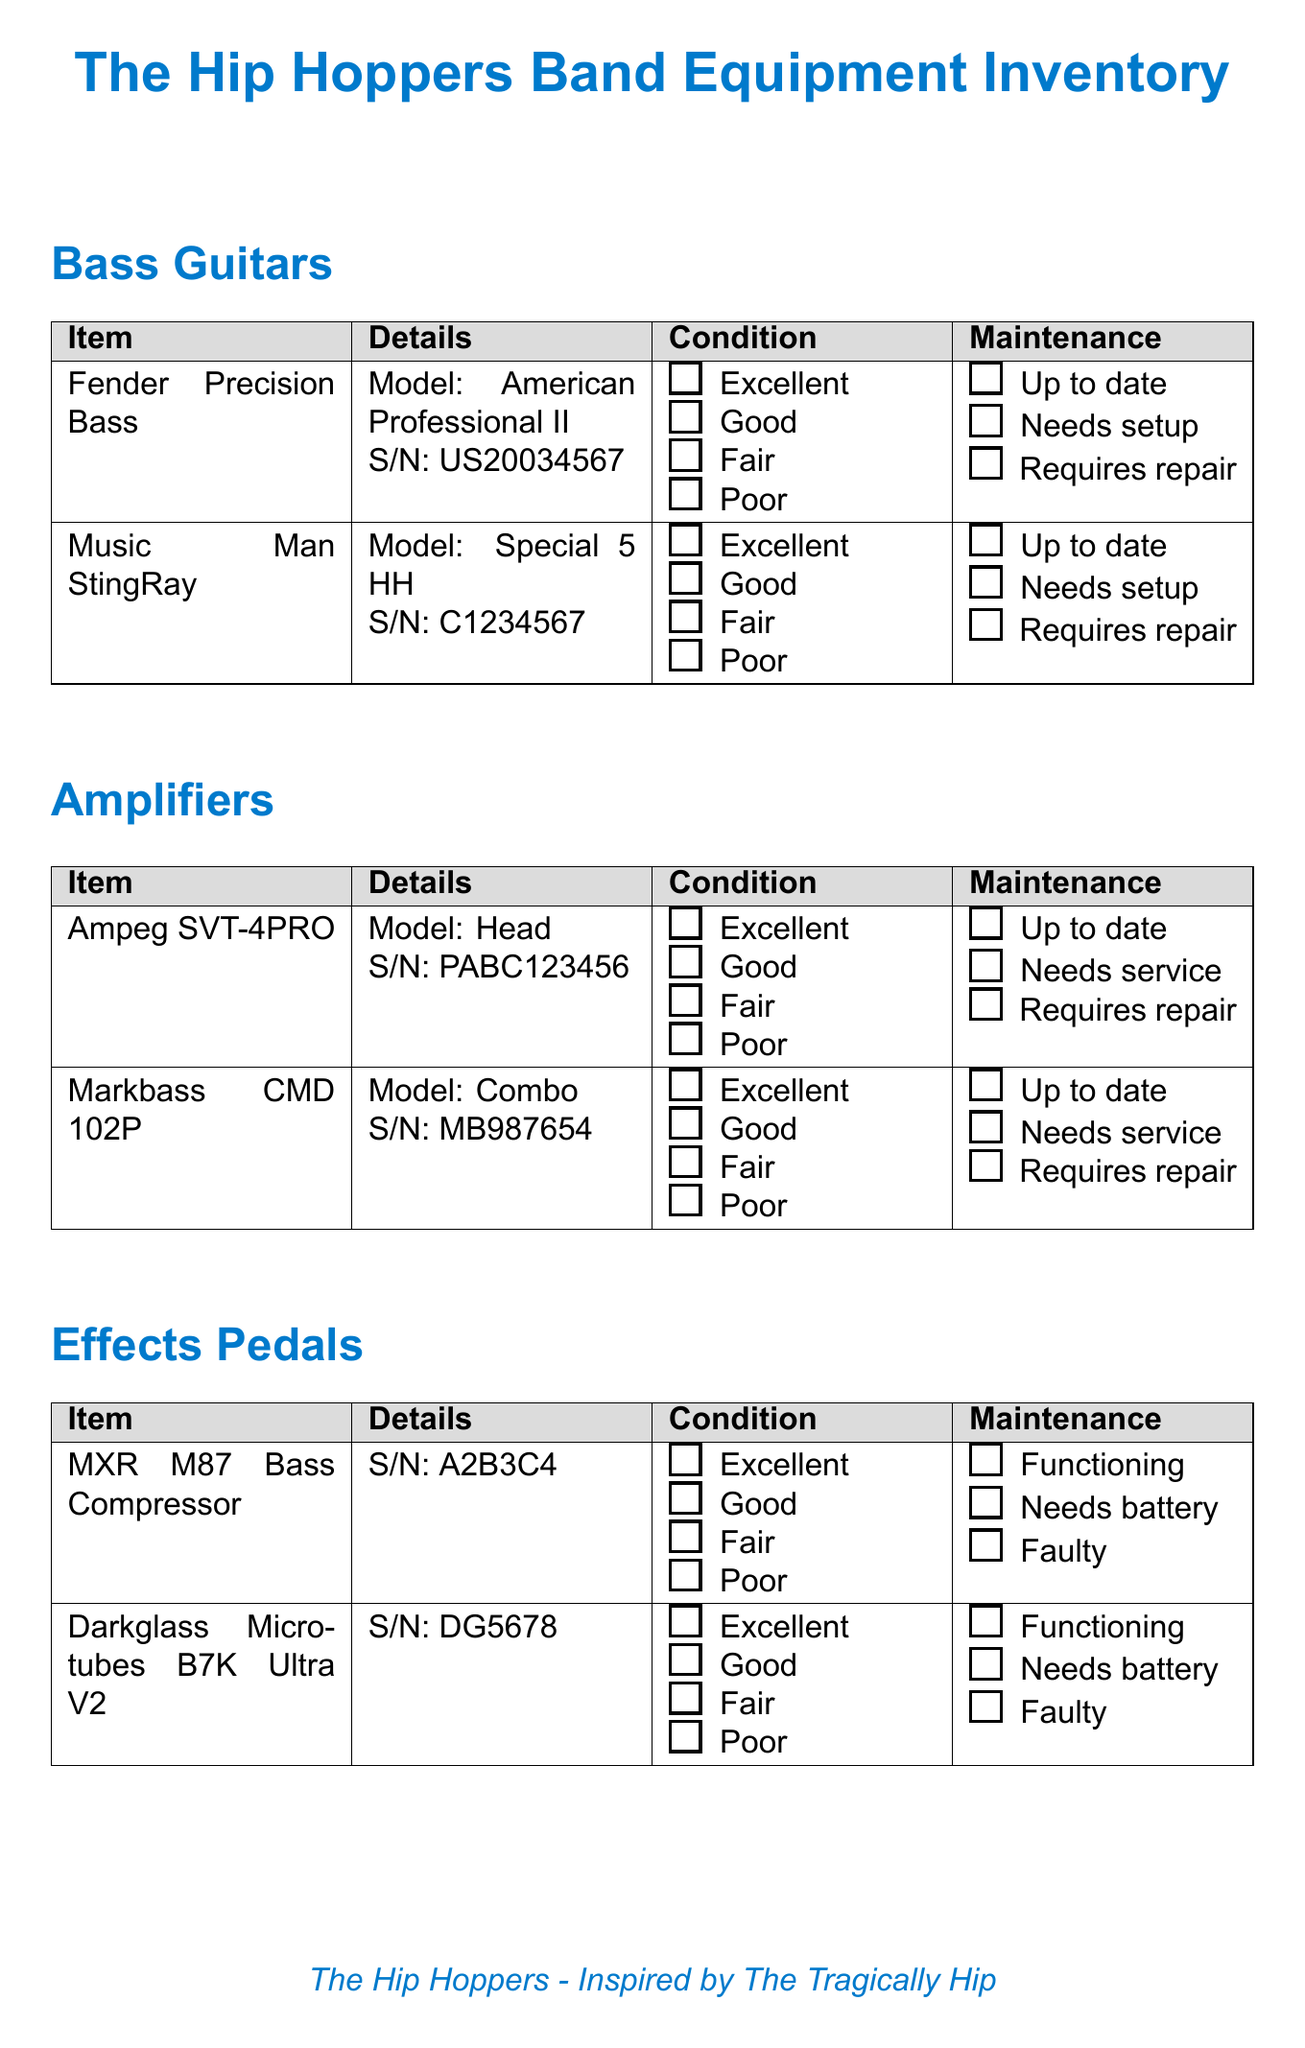What is the title of the document? The title of the document is displayed prominently at the top, labeled as "The Hip Hoppers Band Equipment Inventory."
Answer: The Hip Hoppers Band Equipment Inventory How many bass guitars are listed? The document lists two bass guitars under the "Bass Guitars" category.
Answer: 2 What model is the Music Man StingRay? The model of the Music Man StingRay is specified in the details of the item.
Answer: Special 5 HH What condition options are provided for accessories? The condition options for accessories are detailed in the items under the "Accessories" category.
Answer: Excellent, Good, Fair, Poor What is the last maintenance status for the Ampeg SVT-4PRO? The maintenance status of the Ampeg SVT-4PRO is shown in the maintenance section of the "Amplifiers" category.
Answer: Up to date What color is the Levy's Padded Leather Bass Strap? The color of the Levy's Padded Leather Bass Strap is mentioned in the details section of the item.
Answer: Black How many packs of strings are available? The document states that the quantity for the Ernie Ball Regular Slinky Bass Strings is described as "Number of packs."
Answer: Number of packs When is the next gig scheduled? The next gig is mentioned in the additional notes section along with its location.
Answer: The Horseshoe Tavern, Toronto - YYYY-MM-DD 